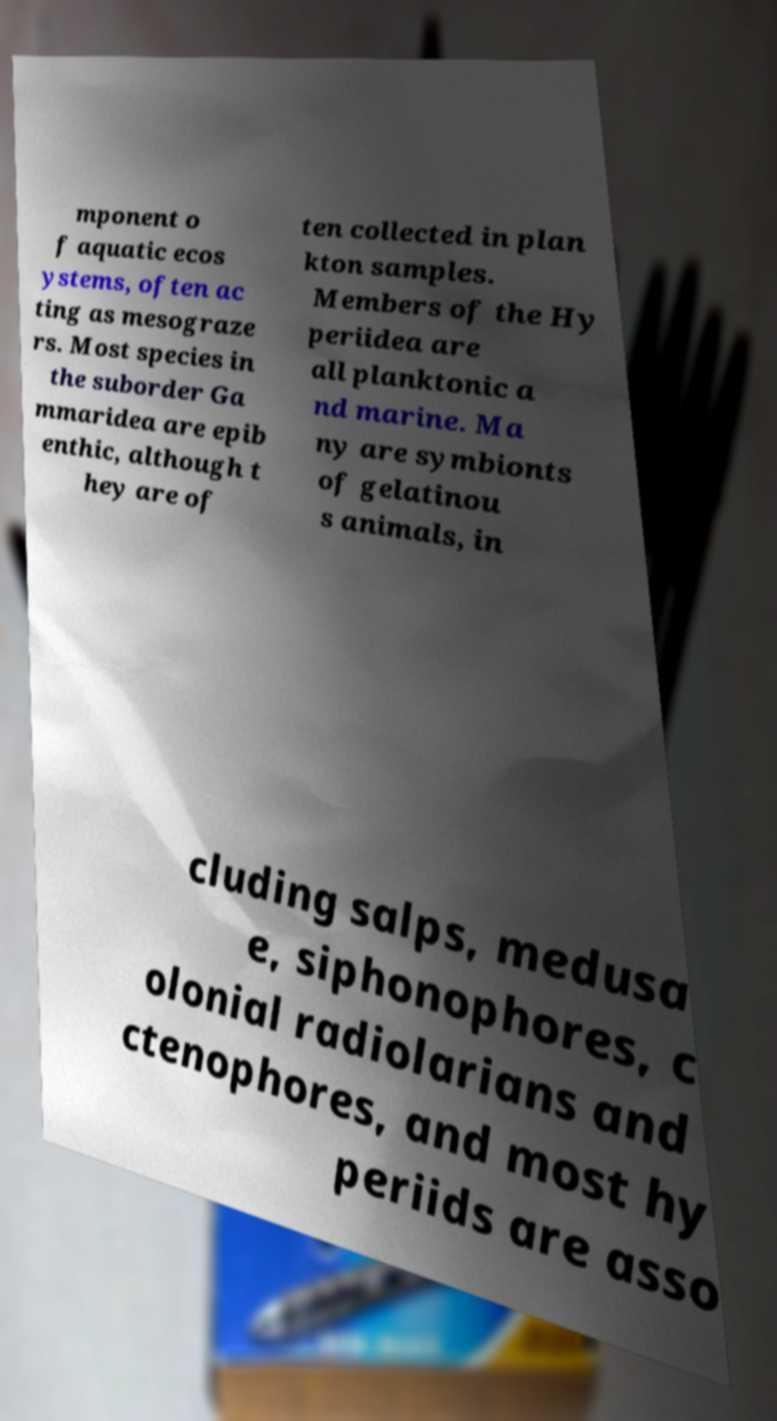Please read and relay the text visible in this image. What does it say? mponent o f aquatic ecos ystems, often ac ting as mesograze rs. Most species in the suborder Ga mmaridea are epib enthic, although t hey are of ten collected in plan kton samples. Members of the Hy periidea are all planktonic a nd marine. Ma ny are symbionts of gelatinou s animals, in cluding salps, medusa e, siphonophores, c olonial radiolarians and ctenophores, and most hy periids are asso 